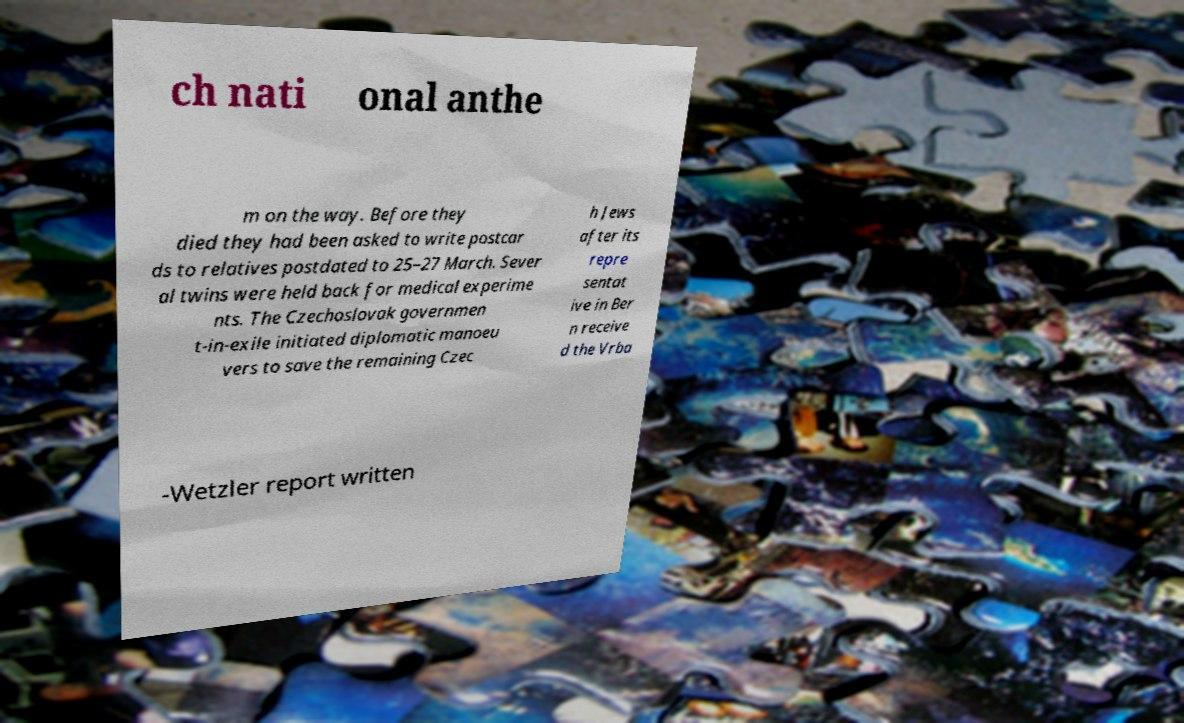Could you extract and type out the text from this image? ch nati onal anthe m on the way. Before they died they had been asked to write postcar ds to relatives postdated to 25–27 March. Sever al twins were held back for medical experime nts. The Czechoslovak governmen t-in-exile initiated diplomatic manoeu vers to save the remaining Czec h Jews after its repre sentat ive in Ber n receive d the Vrba -Wetzler report written 